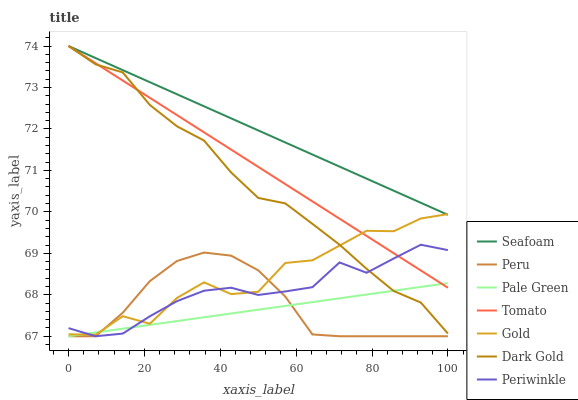Does Pale Green have the minimum area under the curve?
Answer yes or no. Yes. Does Seafoam have the maximum area under the curve?
Answer yes or no. Yes. Does Gold have the minimum area under the curve?
Answer yes or no. No. Does Gold have the maximum area under the curve?
Answer yes or no. No. Is Pale Green the smoothest?
Answer yes or no. Yes. Is Gold the roughest?
Answer yes or no. Yes. Is Dark Gold the smoothest?
Answer yes or no. No. Is Dark Gold the roughest?
Answer yes or no. No. Does Pale Green have the lowest value?
Answer yes or no. Yes. Does Gold have the lowest value?
Answer yes or no. No. Does Seafoam have the highest value?
Answer yes or no. Yes. Does Gold have the highest value?
Answer yes or no. No. Is Peru less than Seafoam?
Answer yes or no. Yes. Is Dark Gold greater than Peru?
Answer yes or no. Yes. Does Pale Green intersect Gold?
Answer yes or no. Yes. Is Pale Green less than Gold?
Answer yes or no. No. Is Pale Green greater than Gold?
Answer yes or no. No. Does Peru intersect Seafoam?
Answer yes or no. No. 